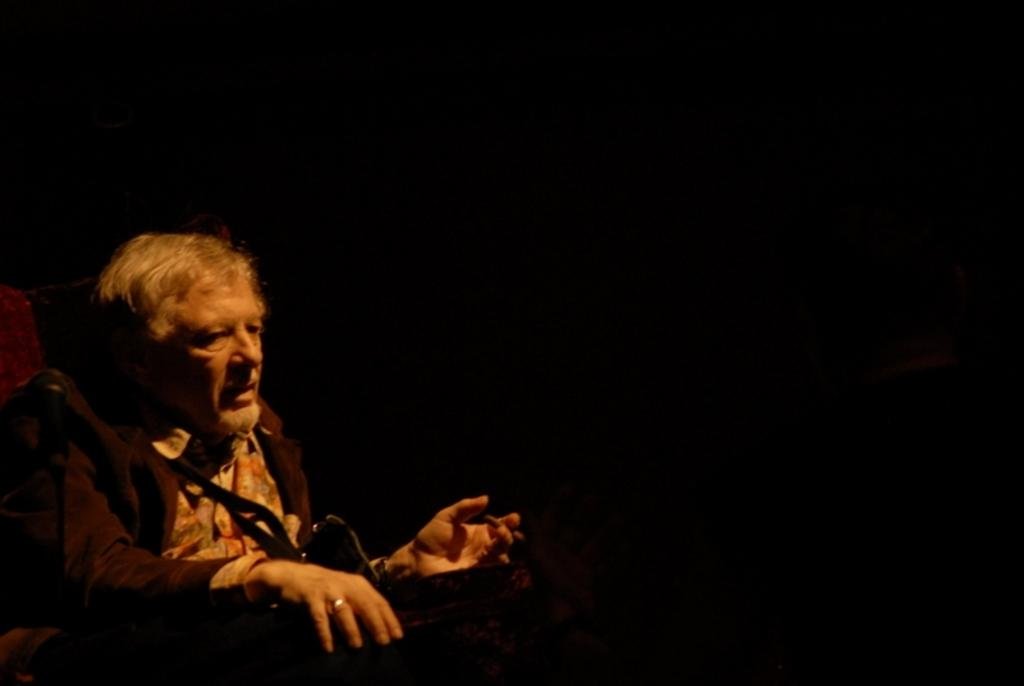What is the position of the man in the image? The man is sitting on the left side in the image. What can be seen in the background of the image? The background of the image is black. What type of nut is being used for arithmetic in the image? There is no nut or arithmetic present in the image. 